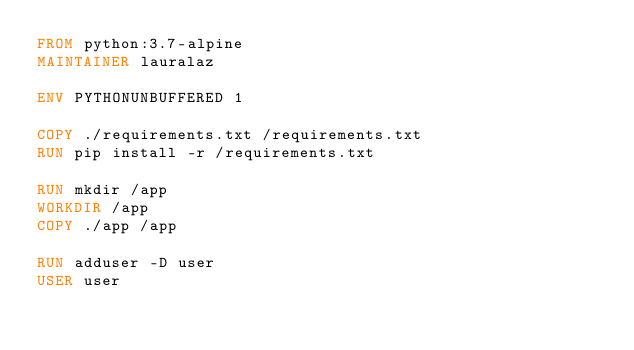Convert code to text. <code><loc_0><loc_0><loc_500><loc_500><_Dockerfile_>FROM python:3.7-alpine
MAINTAINER lauralaz

ENV PYTHONUNBUFFERED 1

COPY ./requirements.txt /requirements.txt
RUN pip install -r /requirements.txt

RUN mkdir /app
WORKDIR /app
COPY ./app /app

RUN adduser -D user
USER user
</code> 